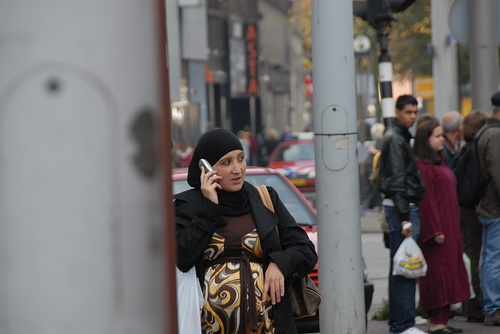Describe the objects in this image and their specific colors. I can see people in gray, black, and maroon tones, people in gray, black, and maroon tones, people in gray, black, and darkgray tones, people in gray, black, blue, and navy tones, and car in gray, darkgray, and black tones in this image. 